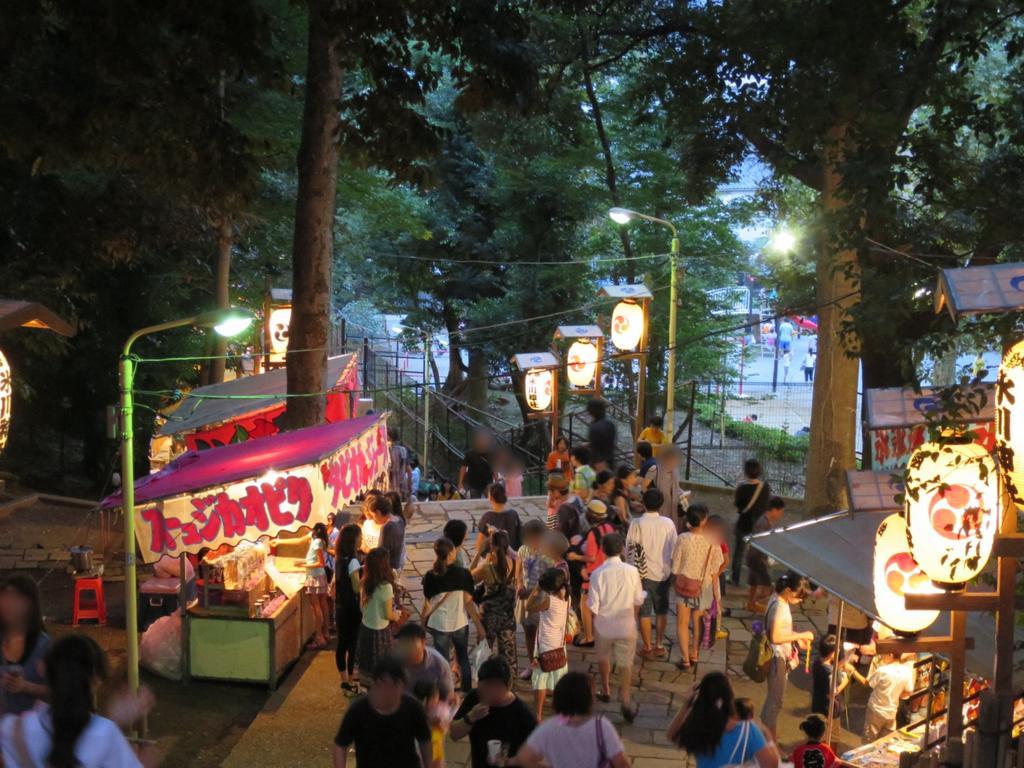Please provide a concise description of this image. In this picture there are people at the bottom side of the image and there are stalls on the right and left side of the image, there are trees at the top side of the image. 